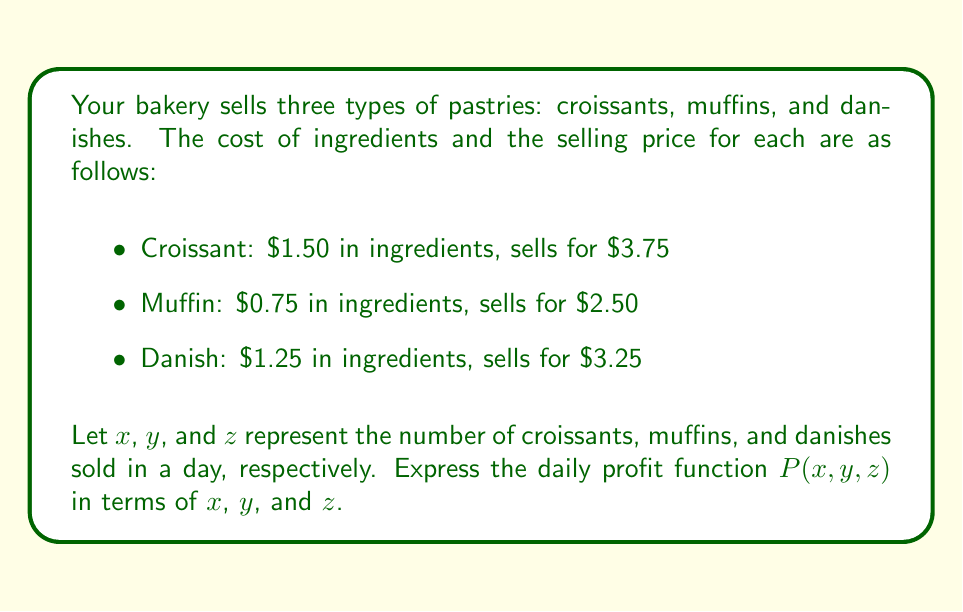Can you solve this math problem? To calculate the profit function, we need to subtract the total cost from the total revenue for all three pastries. Let's break it down step-by-step:

1. Calculate the profit per item:
   - Croissant: $3.75 - $1.50 = $2.25 profit
   - Muffin: $2.50 - $0.75 = $1.75 profit
   - Danish: $3.25 - $1.25 = $2.00 profit

2. Express the profit for each pastry in terms of the variables:
   - Croissants: $2.25x$
   - Muffins: $1.75y$
   - Danishes: $2.00z$

3. Sum up the profits from all three pastries to get the total profit function:

   $P(x,y,z) = 2.25x + 1.75y + 2.00z$

Therefore, the daily profit function $P(x,y,z)$ is:

$$P(x,y,z) = 2.25x + 1.75y + 2.00z$$

This function represents the total profit based on the number of each pastry sold in a day.
Answer: $P(x,y,z) = 2.25x + 1.75y + 2.00z$ 